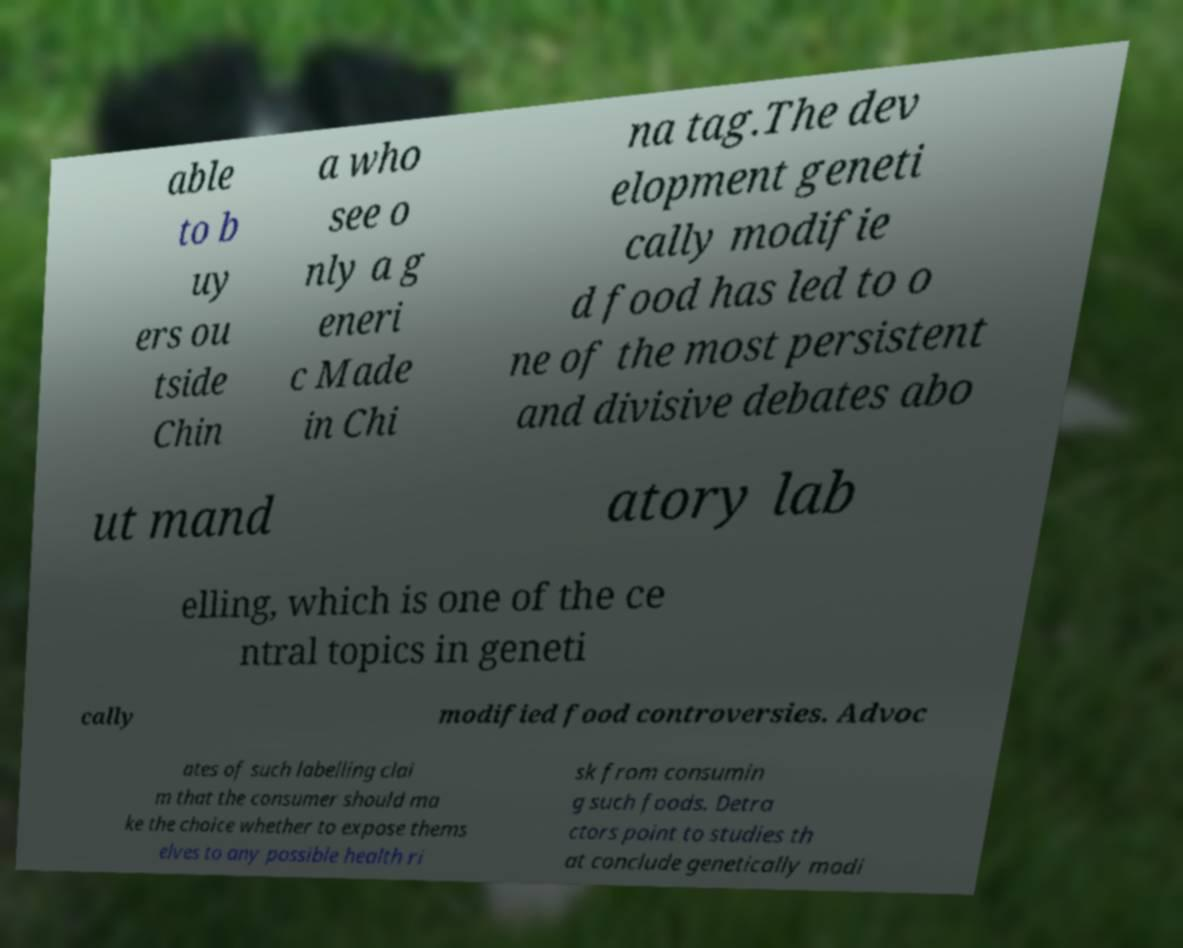For documentation purposes, I need the text within this image transcribed. Could you provide that? able to b uy ers ou tside Chin a who see o nly a g eneri c Made in Chi na tag.The dev elopment geneti cally modifie d food has led to o ne of the most persistent and divisive debates abo ut mand atory lab elling, which is one of the ce ntral topics in geneti cally modified food controversies. Advoc ates of such labelling clai m that the consumer should ma ke the choice whether to expose thems elves to any possible health ri sk from consumin g such foods. Detra ctors point to studies th at conclude genetically modi 